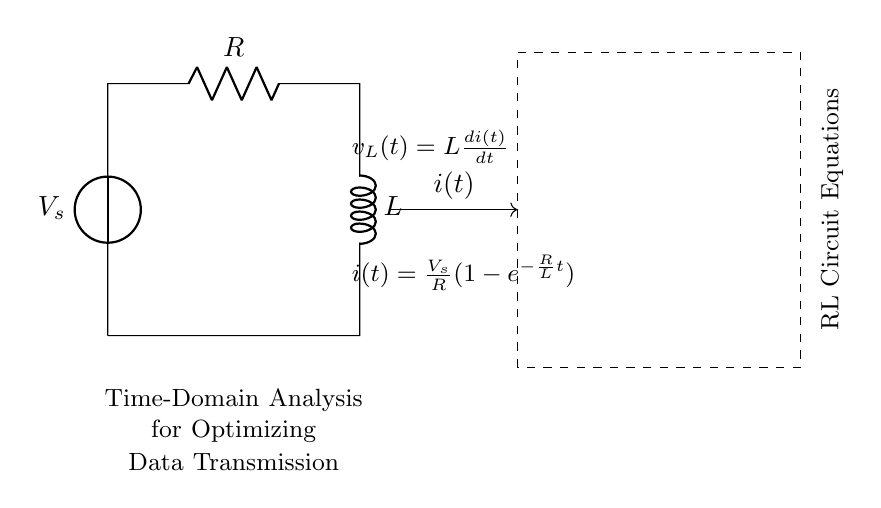What are the components of this circuit? The circuit consists of a voltage source, a resistor, and an inductor. These components are identified by their symbols in the diagram.
Answer: voltage source, resistor, inductor What is the expression for current i(t)? The expression for the current is derived from the equation given in the diagram: i(t) = V_s/R * (1 - e^(-R/L * t)). This shows how the current changes over time in an RL circuit.
Answer: V_s/R(1 - e^(-R/L * t)) What does v_L(t) represent? v_L(t) represents the voltage across the inductor and is defined by the equation v_L(t) = L * di(t)/dt, which describes the rate of change of current through the inductor.
Answer: L(di(t)/dt) How will the current behave over time? The current i(t) will increase exponentially and approach V_s/R as time tends to infinity, indicating that it will eventually reach a steady state.
Answer: approaches V_s/R What is the time constant of this circuit? The time constant τ (tau) is given by the ratio of the resistance to the inductance, τ = R/L. This indicates how quickly the current rises to approximately 63.2% of its final value.
Answer: R/L How does the inductor affect data transmission rates? The inductor introduces lag in current changes which can impact the speed of signal transitions, affecting data transmission rates. A higher inductance can slow down the response time.
Answer: introduces lag What happens to the voltage across the inductor at steady state? At steady state, the inductor behaves like a short circuit, and the voltage across it approaches zero as the current stabilizes.
Answer: approaches zero 